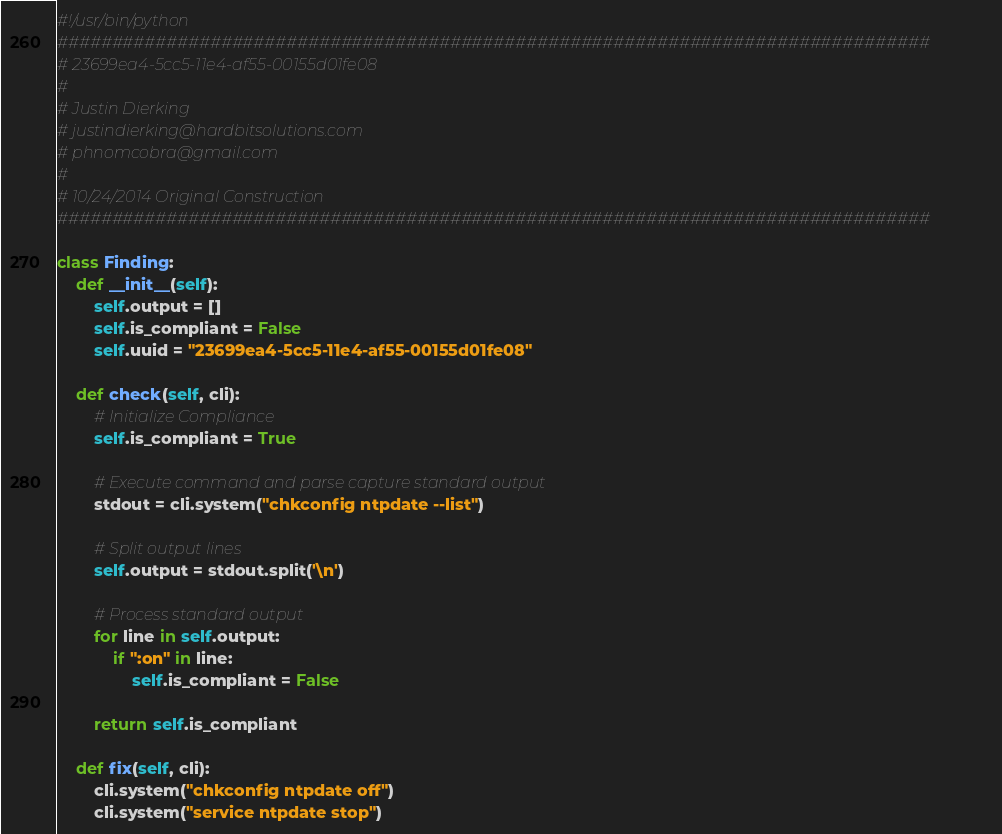Convert code to text. <code><loc_0><loc_0><loc_500><loc_500><_Python_>#!/usr/bin/python
################################################################################
# 23699ea4-5cc5-11e4-af55-00155d01fe08
#
# Justin Dierking
# justindierking@hardbitsolutions.com
# phnomcobra@gmail.com
#
# 10/24/2014 Original Construction
################################################################################

class Finding:
    def __init__(self):
        self.output = []
        self.is_compliant = False
        self.uuid = "23699ea4-5cc5-11e4-af55-00155d01fe08"
        
    def check(self, cli):
        # Initialize Compliance
        self.is_compliant = True
        
        # Execute command and parse capture standard output
        stdout = cli.system("chkconfig ntpdate --list")
        
        # Split output lines
        self.output = stdout.split('\n')

        # Process standard output
        for line in self.output:
            if ":on" in line:
                self.is_compliant = False
        
        return self.is_compliant

    def fix(self, cli):
        cli.system("chkconfig ntpdate off")
        cli.system("service ntpdate stop")
</code> 